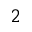<formula> <loc_0><loc_0><loc_500><loc_500>_ { 2 }</formula> 